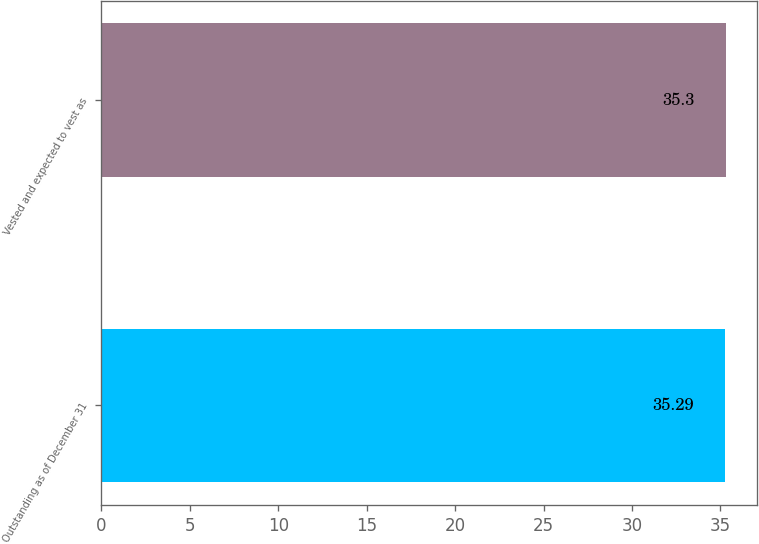Convert chart. <chart><loc_0><loc_0><loc_500><loc_500><bar_chart><fcel>Outstanding as of December 31<fcel>Vested and expected to vest as<nl><fcel>35.29<fcel>35.3<nl></chart> 